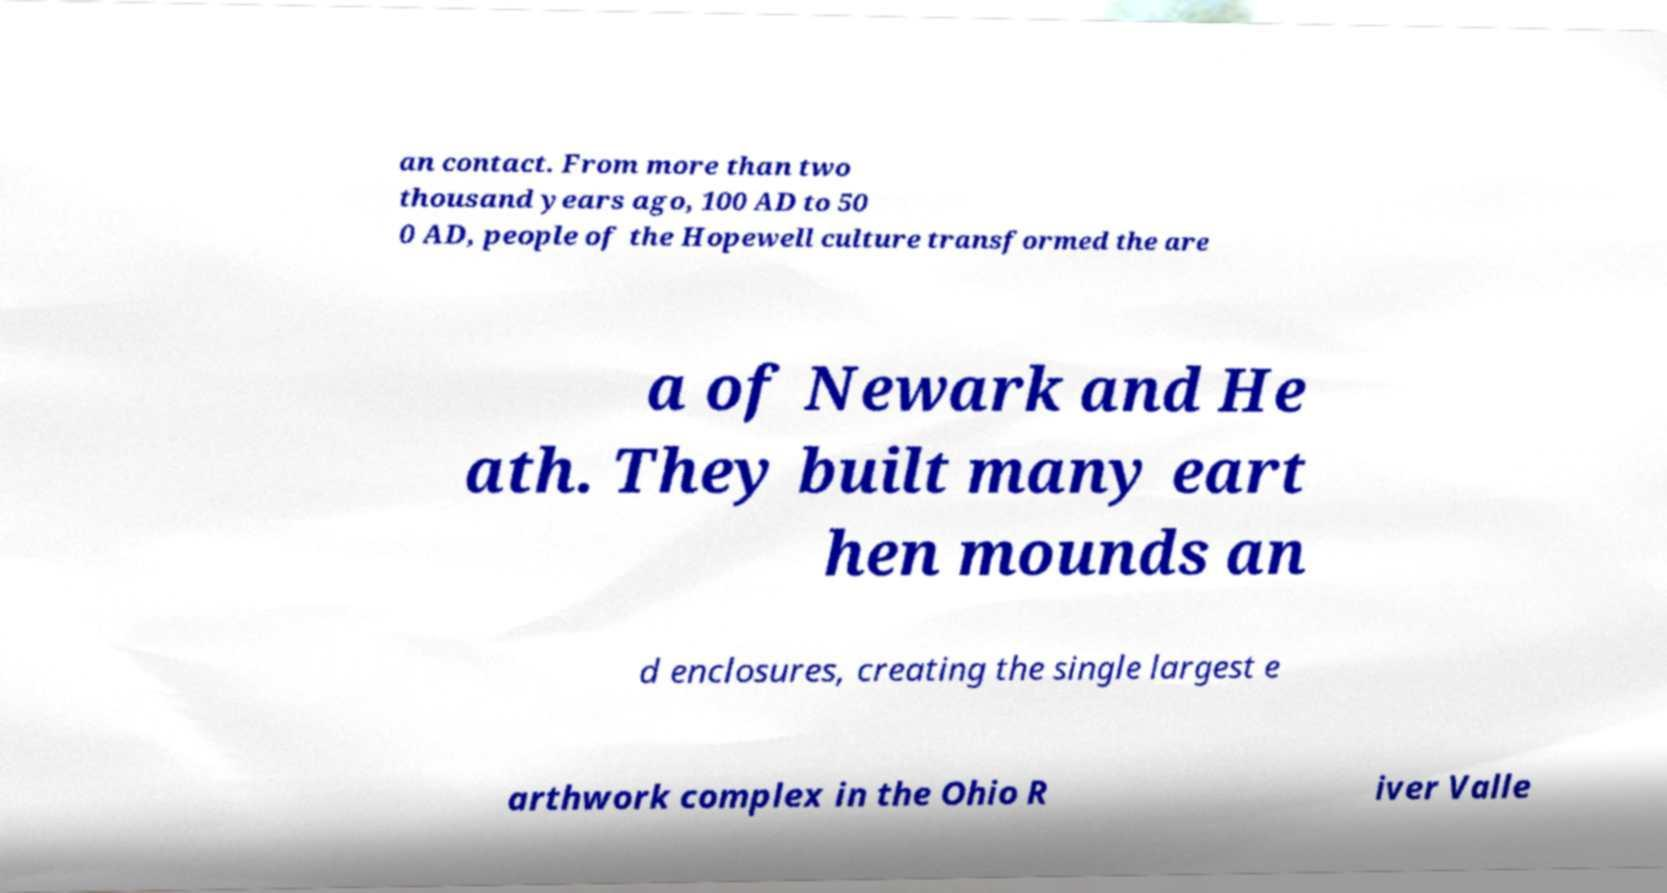I need the written content from this picture converted into text. Can you do that? an contact. From more than two thousand years ago, 100 AD to 50 0 AD, people of the Hopewell culture transformed the are a of Newark and He ath. They built many eart hen mounds an d enclosures, creating the single largest e arthwork complex in the Ohio R iver Valle 